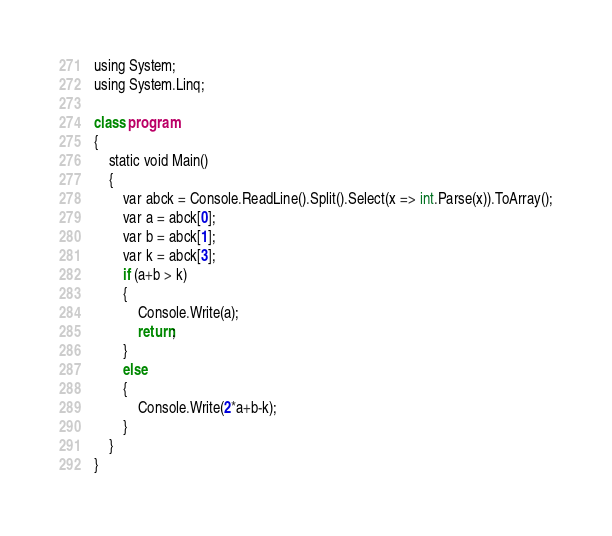<code> <loc_0><loc_0><loc_500><loc_500><_Python_>using System;
using System.Linq;

class program
{
    static void Main()
    {
        var abck = Console.ReadLine().Split().Select(x => int.Parse(x)).ToArray();
        var a = abck[0];
      	var b = abck[1];
      	var k = abck[3];
        if (a+b > k)
        {
            Console.Write(a);
            return;
        }
        else
        {
            Console.Write(2*a+b-k);
        }
    }
}</code> 